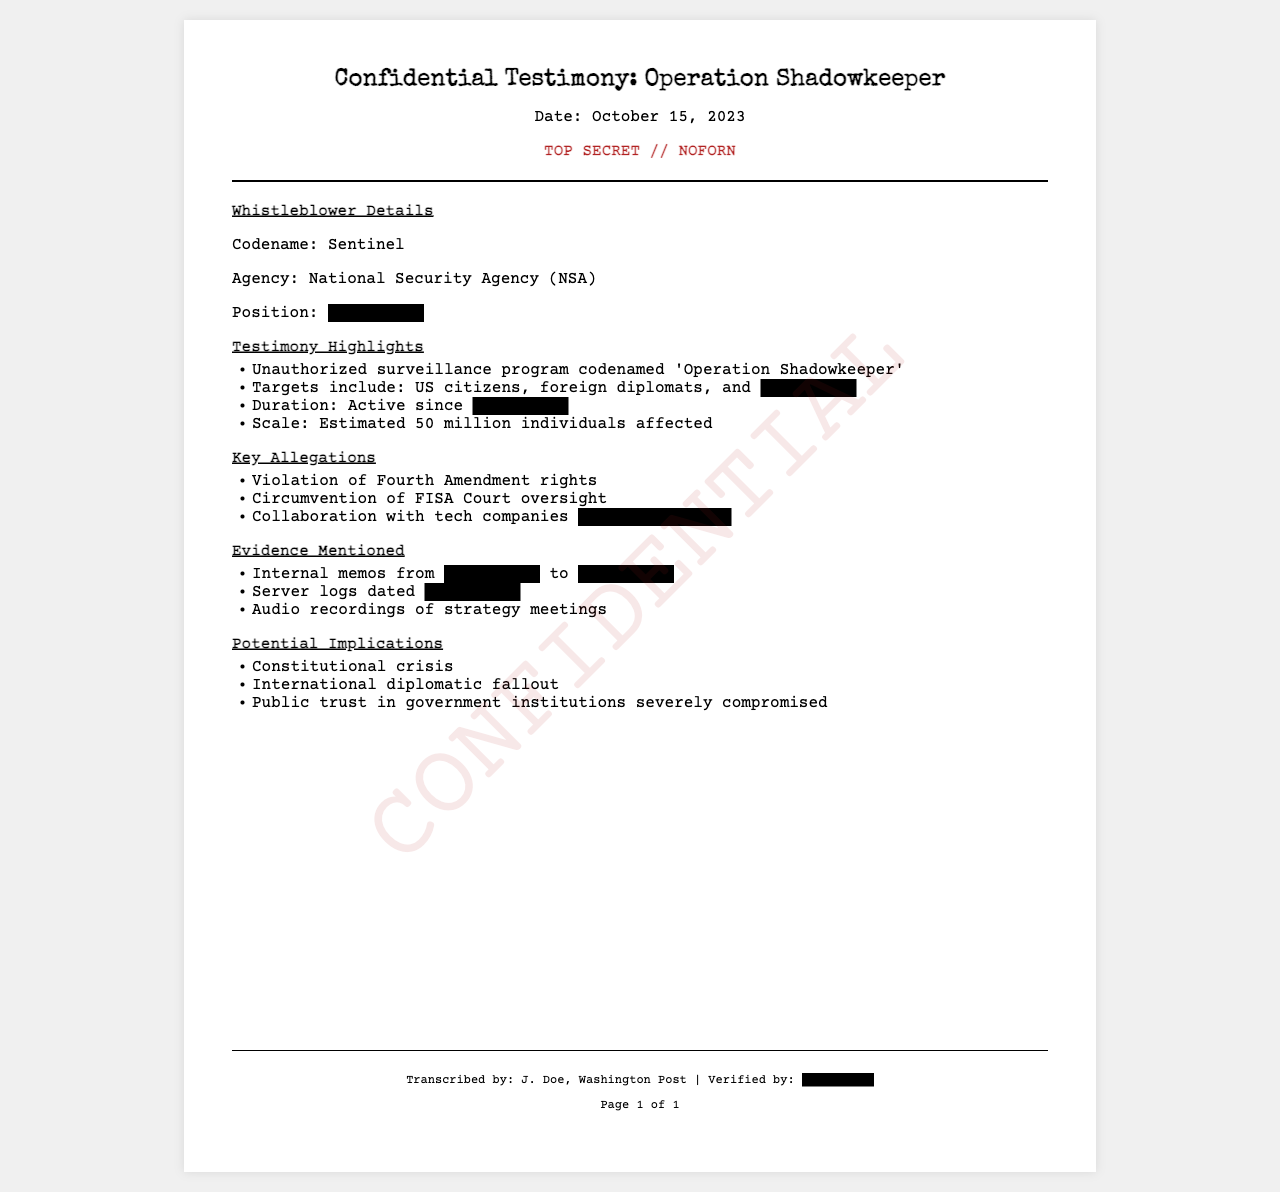What is the codename of the whistleblower? The codename of the whistleblower is mentioned in the document.
Answer: Sentinel Which agency is the whistleblower affiliated with? The document specifies the agency of the whistleblower.
Answer: National Security Agency (NSA) What is the estimated number of individuals affected by the program? The document provides an estimate of how many individuals are affected.
Answer: 50 million What is one of the key allegations mentioned? The document lists several key allegations against the program.
Answer: Violation of Fourth Amendment rights What potential implication is noted regarding public trust? The document discusses implications for public trust in government institutions.
Answer: Severely compromised What is redacted in the whistleblower's position? The specific position of the whistleblower is redacted in the document.
Answer: [REDACTED] From whom were internal memos mentioned as evidence? The document states that internal memos were sent from a redacted source to another redacted source.
Answer: [REDACTED] What date was the testimony dated? The document explicitly states the date.
Answer: October 15, 2023 Which court's oversight is mentioned as being circumvented? The document points to a specific court associated with oversight issues in the allegations.
Answer: FISA Court What is the classification level of this document? The document has a specific classification mentioned at the top.
Answer: TOP SECRET // NOFORN 